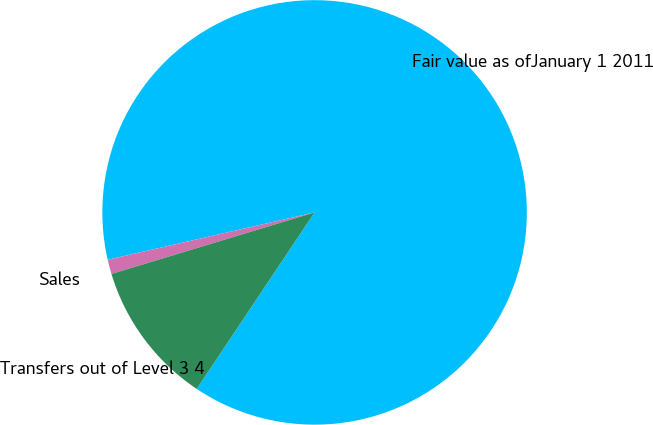Convert chart. <chart><loc_0><loc_0><loc_500><loc_500><pie_chart><fcel>Fair value as ofJanuary 1 2011<fcel>Sales<fcel>Transfers out of Level 3 4<nl><fcel>87.95%<fcel>1.1%<fcel>10.95%<nl></chart> 